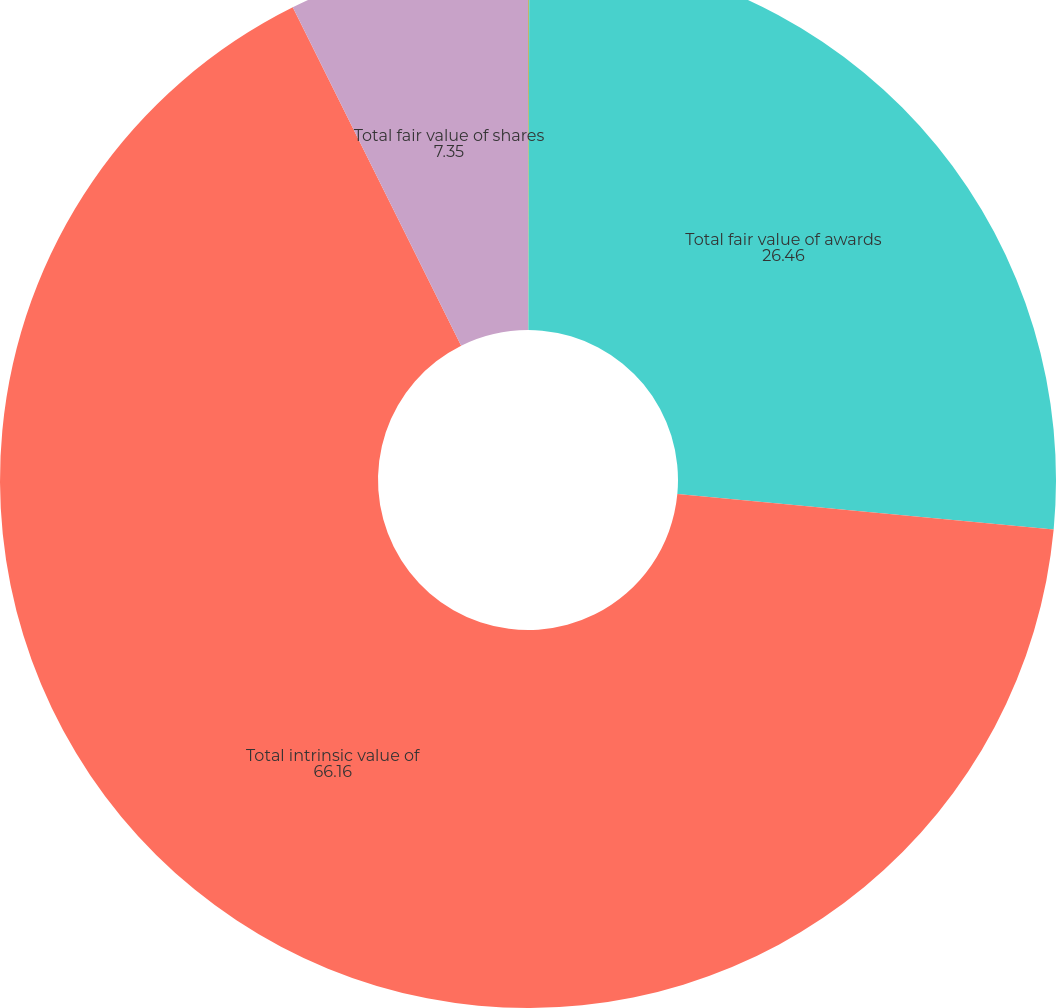Convert chart to OTSL. <chart><loc_0><loc_0><loc_500><loc_500><pie_chart><fcel>Weighted average grant date<fcel>Total fair value of awards<fcel>Total intrinsic value of<fcel>Total fair value of shares<nl><fcel>0.04%<fcel>26.46%<fcel>66.16%<fcel>7.35%<nl></chart> 